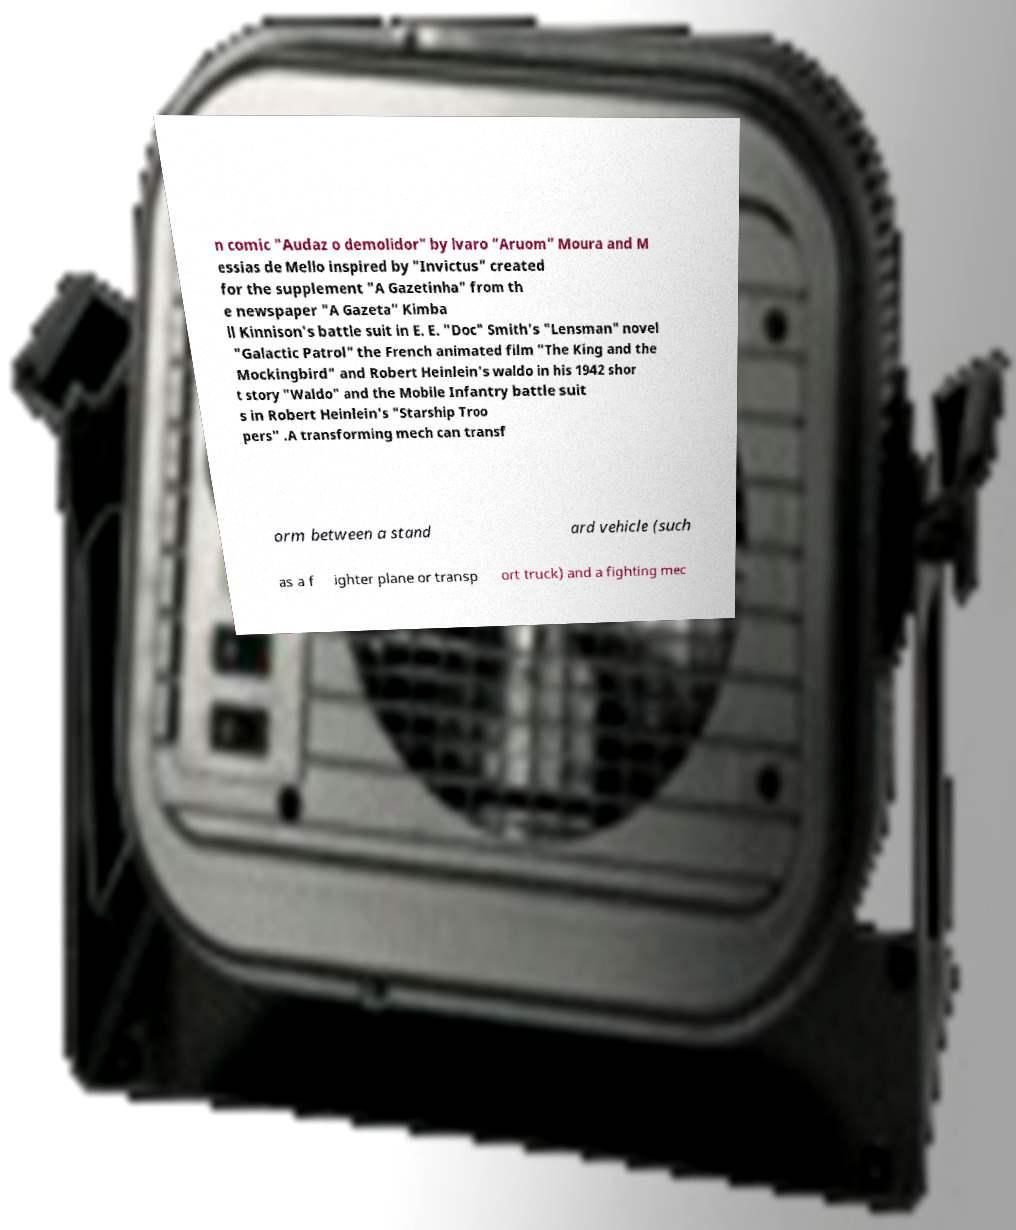Could you extract and type out the text from this image? n comic "Audaz o demolidor" by lvaro "Aruom" Moura and M essias de Mello inspired by "Invictus" created for the supplement "A Gazetinha" from th e newspaper "A Gazeta" Kimba ll Kinnison's battle suit in E. E. "Doc" Smith's "Lensman" novel "Galactic Patrol" the French animated film "The King and the Mockingbird" and Robert Heinlein's waldo in his 1942 shor t story "Waldo" and the Mobile Infantry battle suit s in Robert Heinlein's "Starship Troo pers" .A transforming mech can transf orm between a stand ard vehicle (such as a f ighter plane or transp ort truck) and a fighting mec 